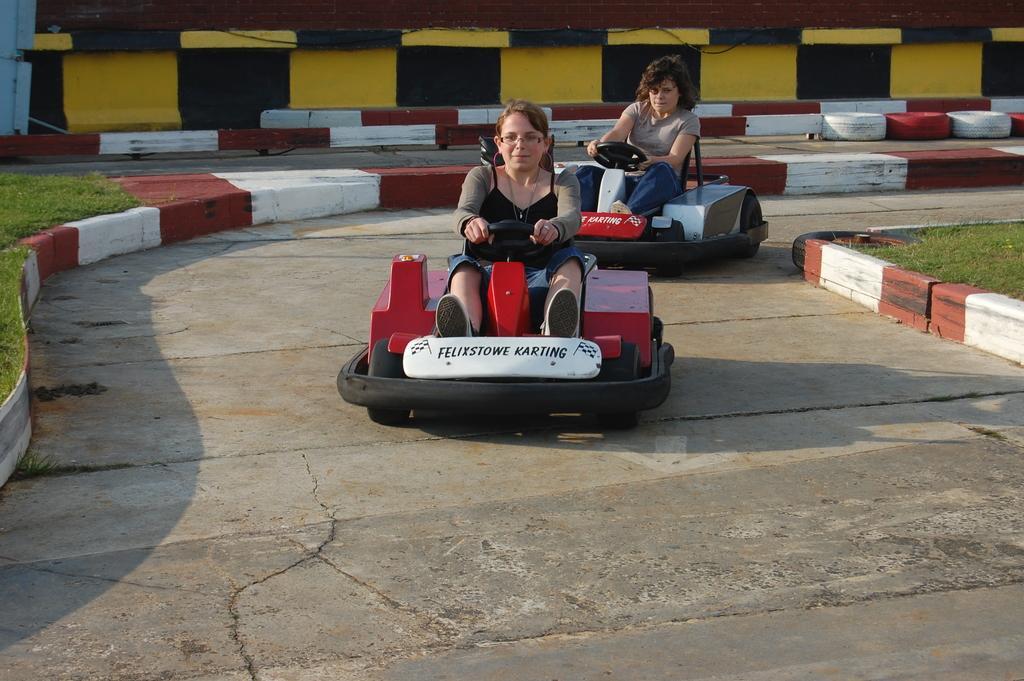How would you summarize this image in a sentence or two? In this image there are two persons sitting on the go kart cars , and in the background there are tires, grass. 